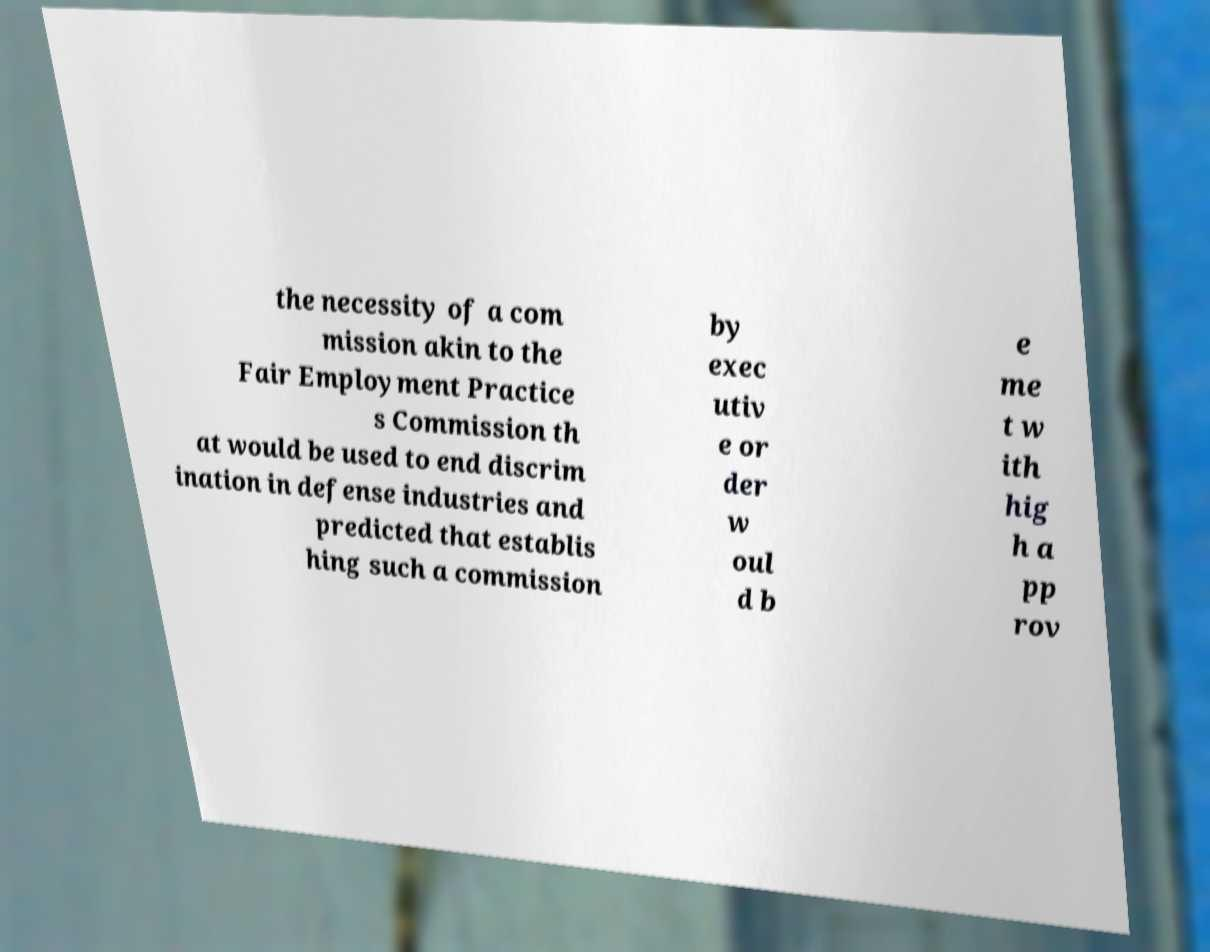Can you read and provide the text displayed in the image?This photo seems to have some interesting text. Can you extract and type it out for me? the necessity of a com mission akin to the Fair Employment Practice s Commission th at would be used to end discrim ination in defense industries and predicted that establis hing such a commission by exec utiv e or der w oul d b e me t w ith hig h a pp rov 